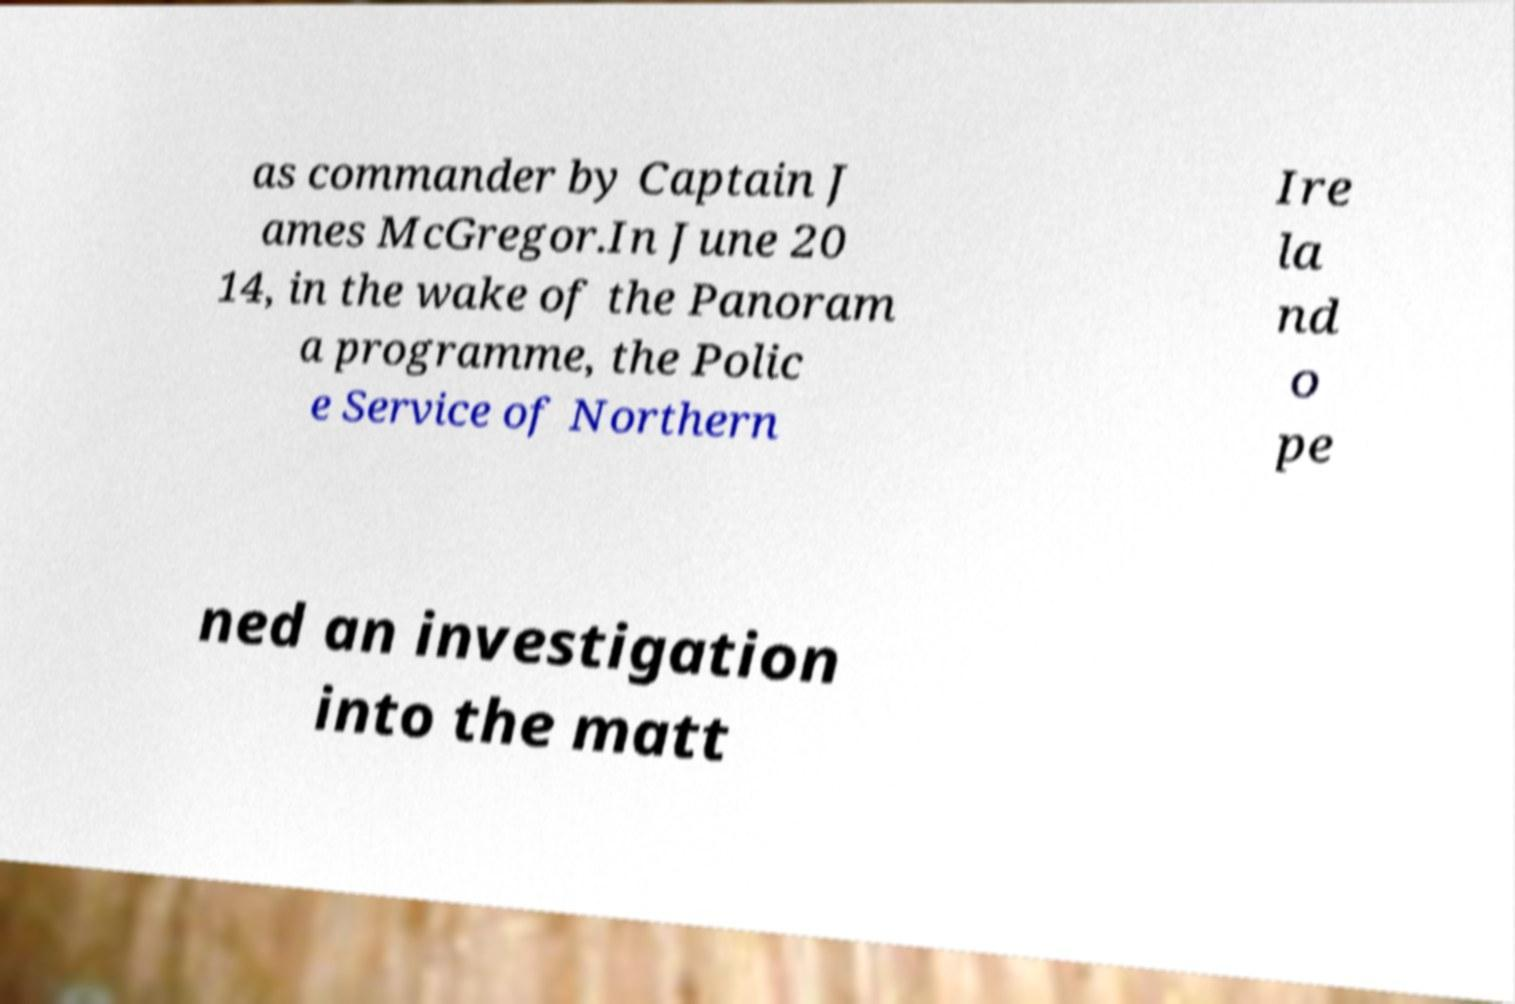I need the written content from this picture converted into text. Can you do that? as commander by Captain J ames McGregor.In June 20 14, in the wake of the Panoram a programme, the Polic e Service of Northern Ire la nd o pe ned an investigation into the matt 